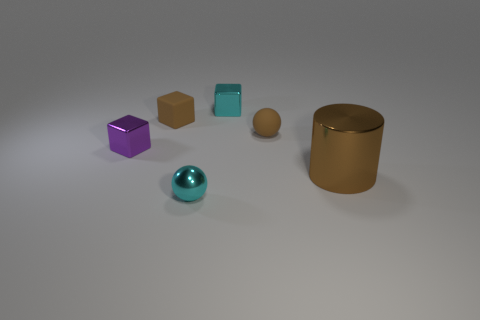What number of blocks are either tiny purple metallic objects or small objects?
Make the answer very short. 3. There is a tiny cube that is the same color as the large object; what is its material?
Make the answer very short. Rubber. Is the shape of the small matte object that is on the left side of the small cyan ball the same as the tiny metallic object to the left of the metal ball?
Ensure brevity in your answer.  Yes. The tiny metal object that is both on the right side of the purple shiny cube and behind the big brown cylinder is what color?
Make the answer very short. Cyan. Does the rubber sphere have the same color as the tiny sphere that is in front of the matte ball?
Keep it short and to the point. No. What is the size of the thing that is in front of the brown rubber sphere and behind the large brown metal thing?
Keep it short and to the point. Small. What number of other things are there of the same color as the big shiny cylinder?
Ensure brevity in your answer.  2. There is a sphere that is to the right of the cyan metal object that is right of the shiny thing that is in front of the brown metallic cylinder; what is its size?
Make the answer very short. Small. Are there any rubber cubes in front of the big metal object?
Give a very brief answer. No. Does the brown metal object have the same size as the brown object to the left of the tiny brown ball?
Make the answer very short. No. 